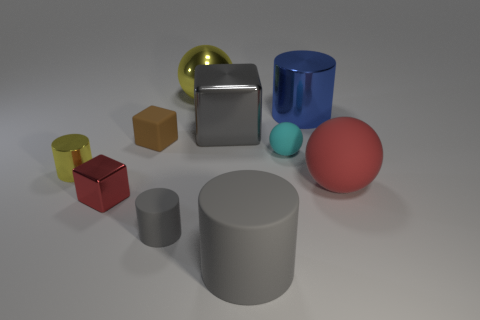Subtract all gray cylinders. How many were subtracted if there are1gray cylinders left? 1 Subtract all cubes. How many objects are left? 7 Subtract all gray metallic balls. Subtract all red rubber things. How many objects are left? 9 Add 1 red matte spheres. How many red matte spheres are left? 2 Add 3 purple cylinders. How many purple cylinders exist? 3 Subtract 0 purple cylinders. How many objects are left? 10 